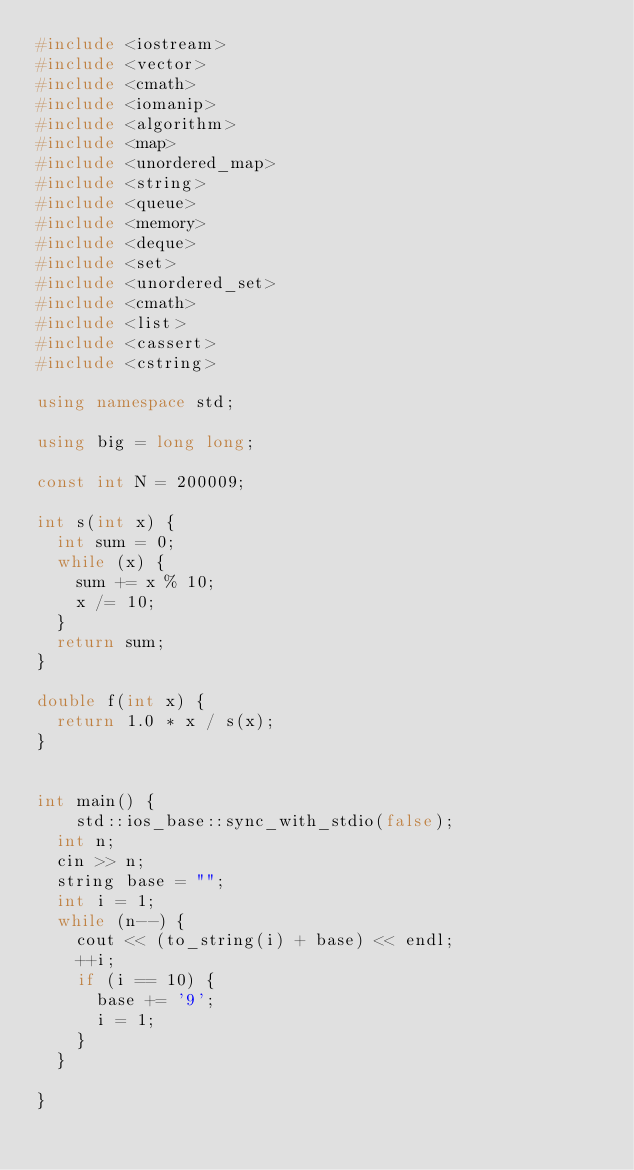<code> <loc_0><loc_0><loc_500><loc_500><_C++_>#include <iostream>
#include <vector>
#include <cmath>
#include <iomanip>
#include <algorithm>
#include <map>
#include <unordered_map>
#include <string>
#include <queue>
#include <memory>
#include <deque>
#include <set>
#include <unordered_set>
#include <cmath>
#include <list>
#include <cassert>
#include <cstring>

using namespace std;

using big = long long;

const int N = 200009;

int s(int x) {
  int sum = 0;
  while (x) {
    sum += x % 10;
    x /= 10;
  }
  return sum;
}

double f(int x) {
  return 1.0 * x / s(x);
}


int main() {
	std::ios_base::sync_with_stdio(false);
  int n;
  cin >> n;
  string base = "";
  int i = 1;
  while (n--) {
    cout << (to_string(i) + base) << endl;
    ++i;
    if (i == 10) {
      base += '9';
      i = 1;
    }
  }
  
}
</code> 